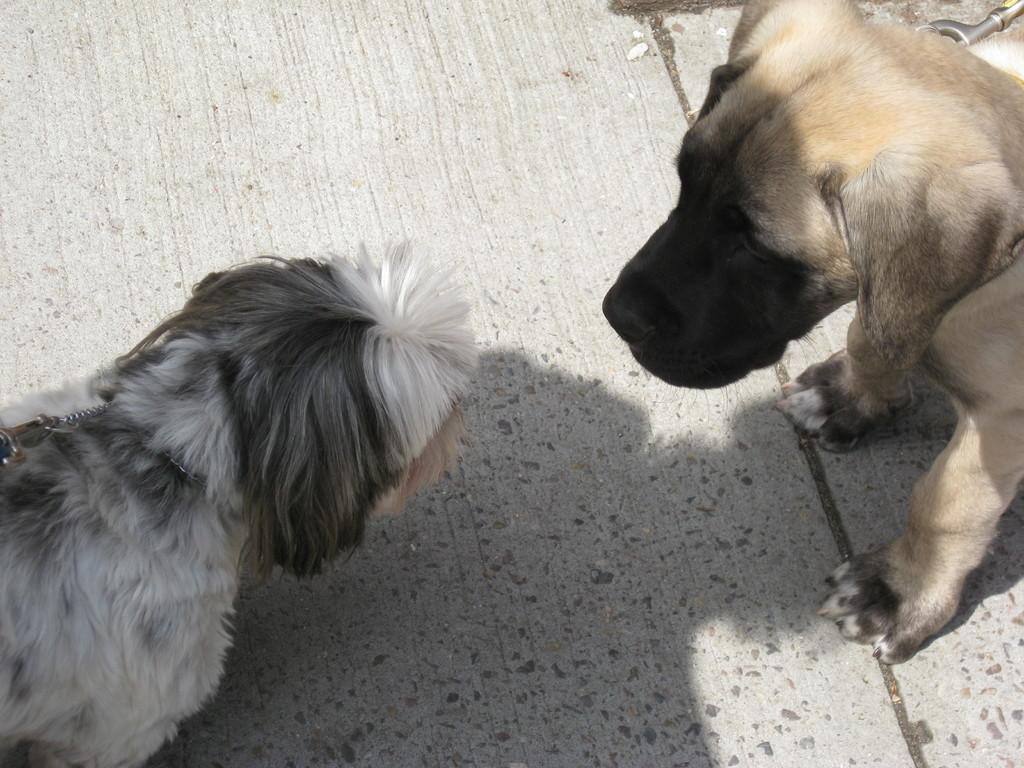How many dogs are present in the image? There are two dogs in the image. Where are the dogs located in the image? The dogs are on the ground. What statement did the authority make about the pest in the image? There is no authority or pest present in the image, as it only features two dogs on the ground. 